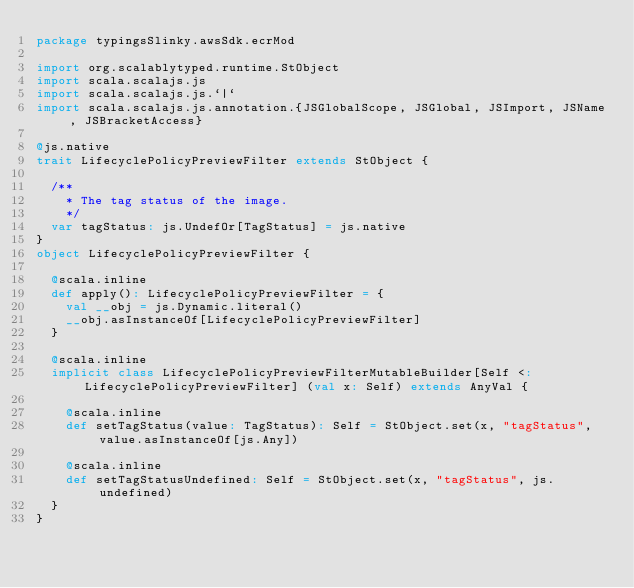<code> <loc_0><loc_0><loc_500><loc_500><_Scala_>package typingsSlinky.awsSdk.ecrMod

import org.scalablytyped.runtime.StObject
import scala.scalajs.js
import scala.scalajs.js.`|`
import scala.scalajs.js.annotation.{JSGlobalScope, JSGlobal, JSImport, JSName, JSBracketAccess}

@js.native
trait LifecyclePolicyPreviewFilter extends StObject {
  
  /**
    * The tag status of the image.
    */
  var tagStatus: js.UndefOr[TagStatus] = js.native
}
object LifecyclePolicyPreviewFilter {
  
  @scala.inline
  def apply(): LifecyclePolicyPreviewFilter = {
    val __obj = js.Dynamic.literal()
    __obj.asInstanceOf[LifecyclePolicyPreviewFilter]
  }
  
  @scala.inline
  implicit class LifecyclePolicyPreviewFilterMutableBuilder[Self <: LifecyclePolicyPreviewFilter] (val x: Self) extends AnyVal {
    
    @scala.inline
    def setTagStatus(value: TagStatus): Self = StObject.set(x, "tagStatus", value.asInstanceOf[js.Any])
    
    @scala.inline
    def setTagStatusUndefined: Self = StObject.set(x, "tagStatus", js.undefined)
  }
}
</code> 